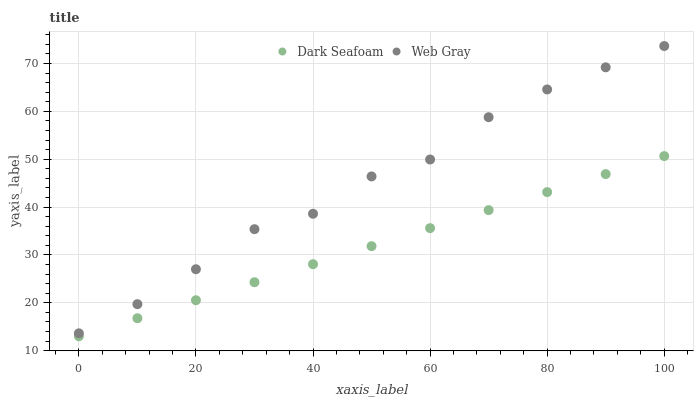Does Dark Seafoam have the minimum area under the curve?
Answer yes or no. Yes. Does Web Gray have the maximum area under the curve?
Answer yes or no. Yes. Does Web Gray have the minimum area under the curve?
Answer yes or no. No. Is Dark Seafoam the smoothest?
Answer yes or no. Yes. Is Web Gray the roughest?
Answer yes or no. Yes. Is Web Gray the smoothest?
Answer yes or no. No. Does Dark Seafoam have the lowest value?
Answer yes or no. Yes. Does Web Gray have the lowest value?
Answer yes or no. No. Does Web Gray have the highest value?
Answer yes or no. Yes. Is Dark Seafoam less than Web Gray?
Answer yes or no. Yes. Is Web Gray greater than Dark Seafoam?
Answer yes or no. Yes. Does Dark Seafoam intersect Web Gray?
Answer yes or no. No. 